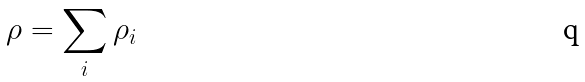Convert formula to latex. <formula><loc_0><loc_0><loc_500><loc_500>\rho = \sum _ { i } \rho _ { i }</formula> 